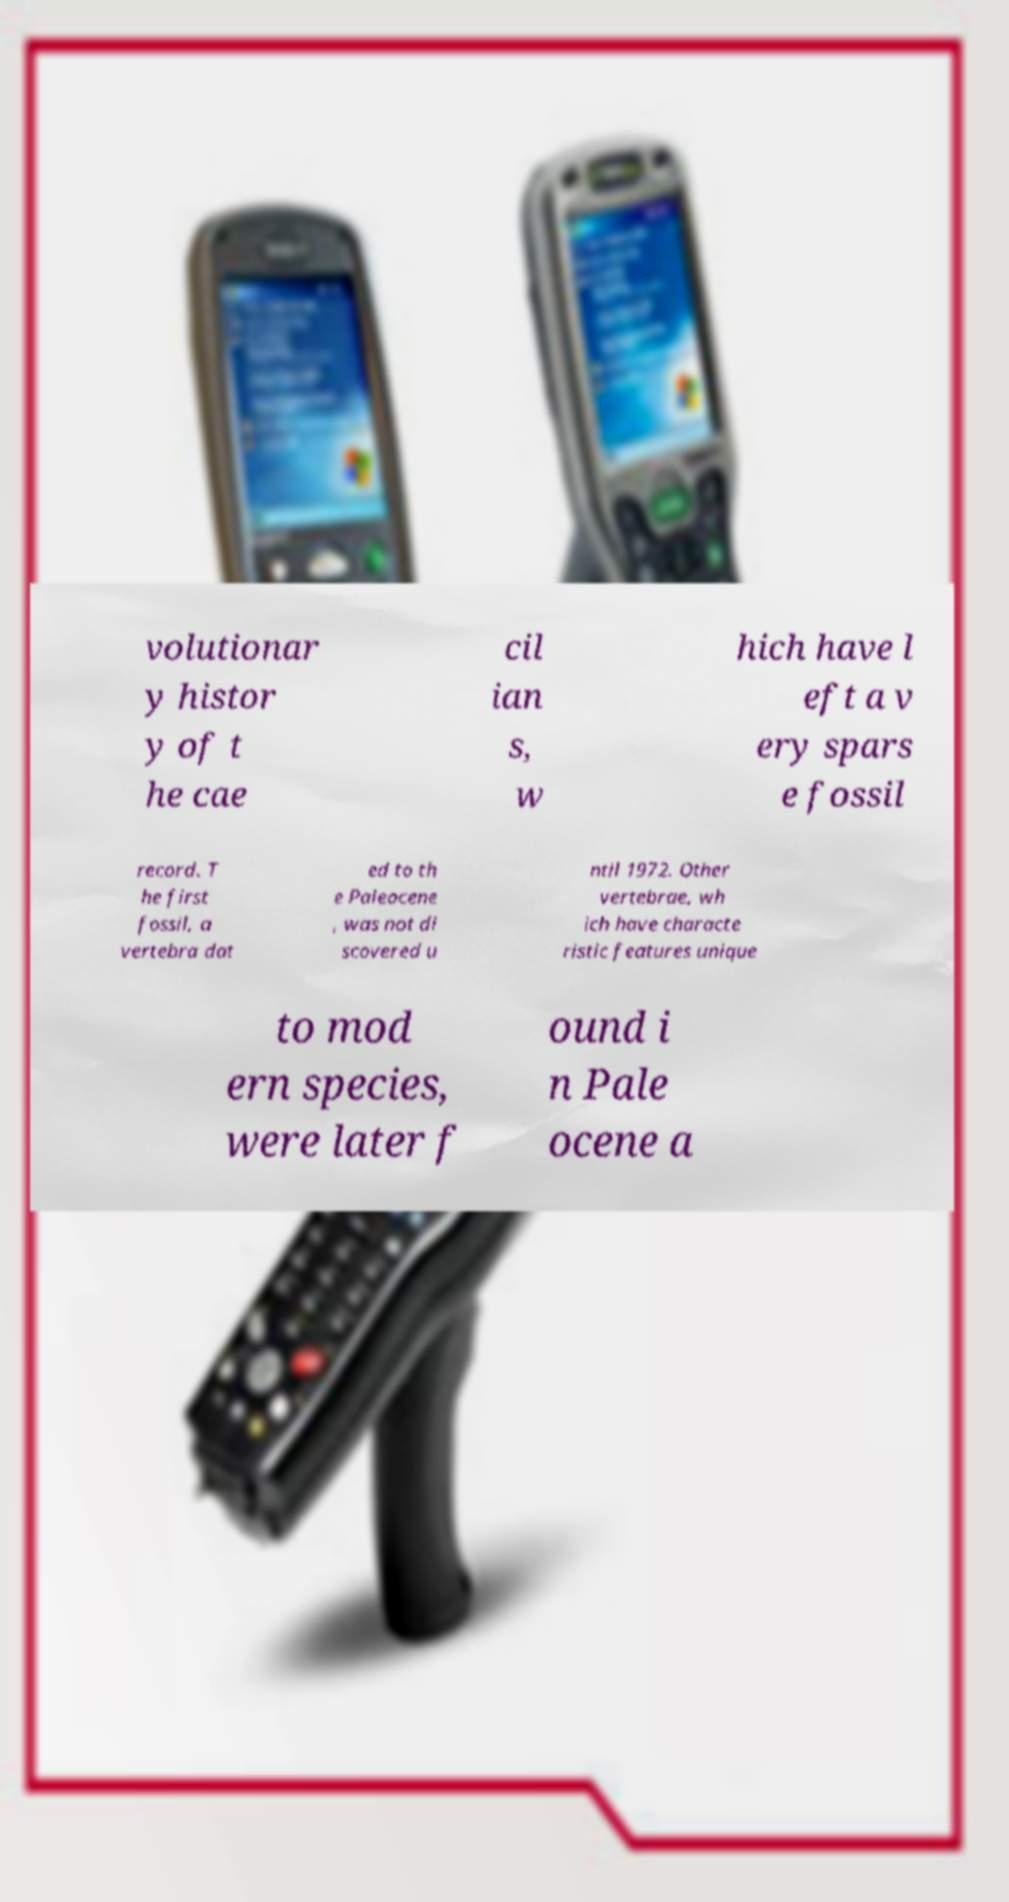There's text embedded in this image that I need extracted. Can you transcribe it verbatim? volutionar y histor y of t he cae cil ian s, w hich have l eft a v ery spars e fossil record. T he first fossil, a vertebra dat ed to th e Paleocene , was not di scovered u ntil 1972. Other vertebrae, wh ich have characte ristic features unique to mod ern species, were later f ound i n Pale ocene a 